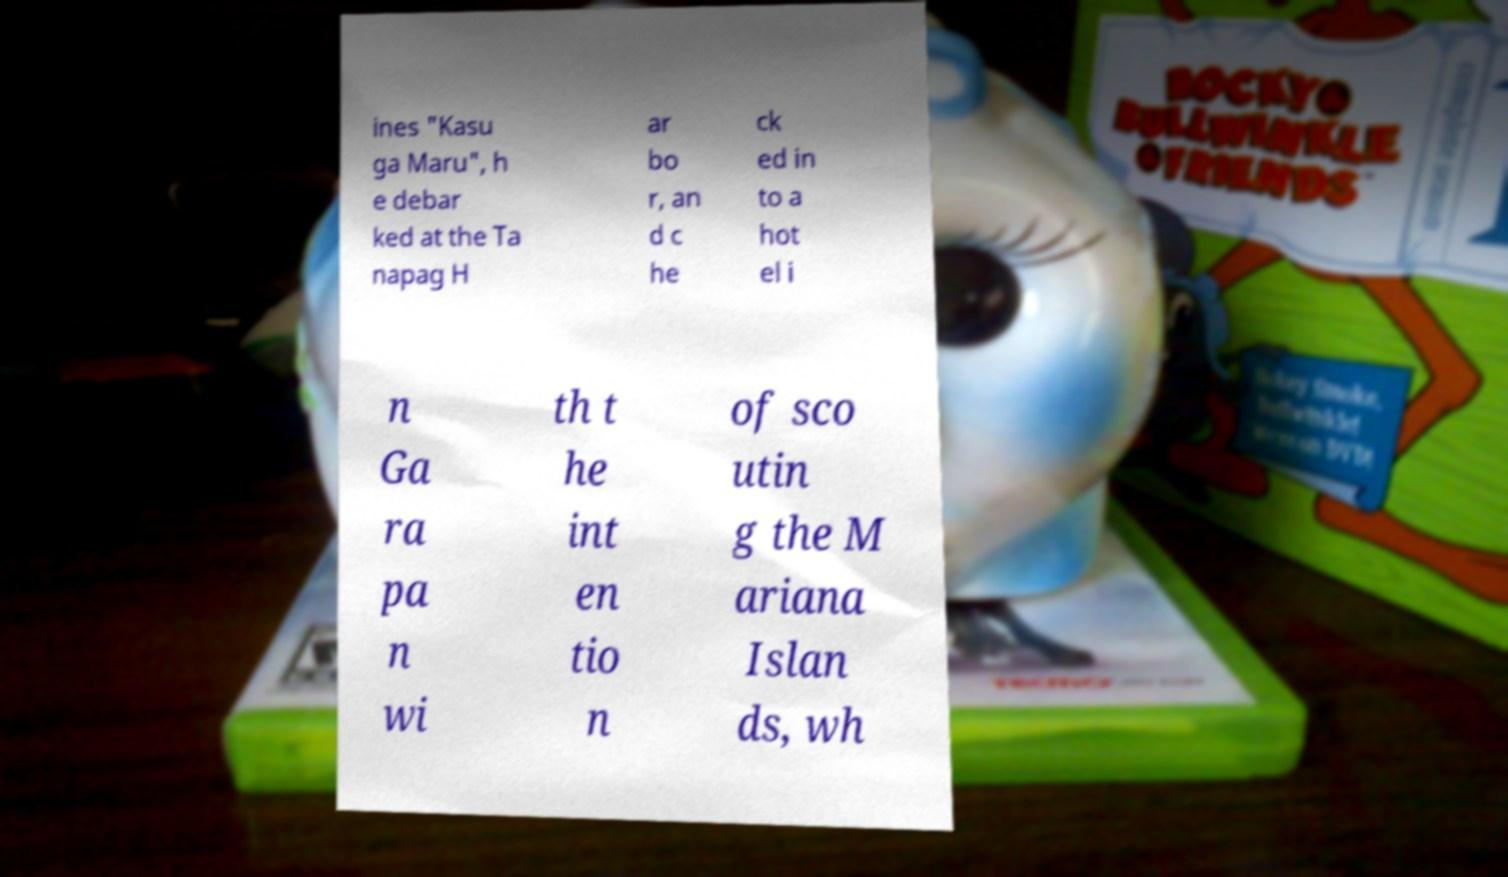Could you assist in decoding the text presented in this image and type it out clearly? ines "Kasu ga Maru", h e debar ked at the Ta napag H ar bo r, an d c he ck ed in to a hot el i n Ga ra pa n wi th t he int en tio n of sco utin g the M ariana Islan ds, wh 